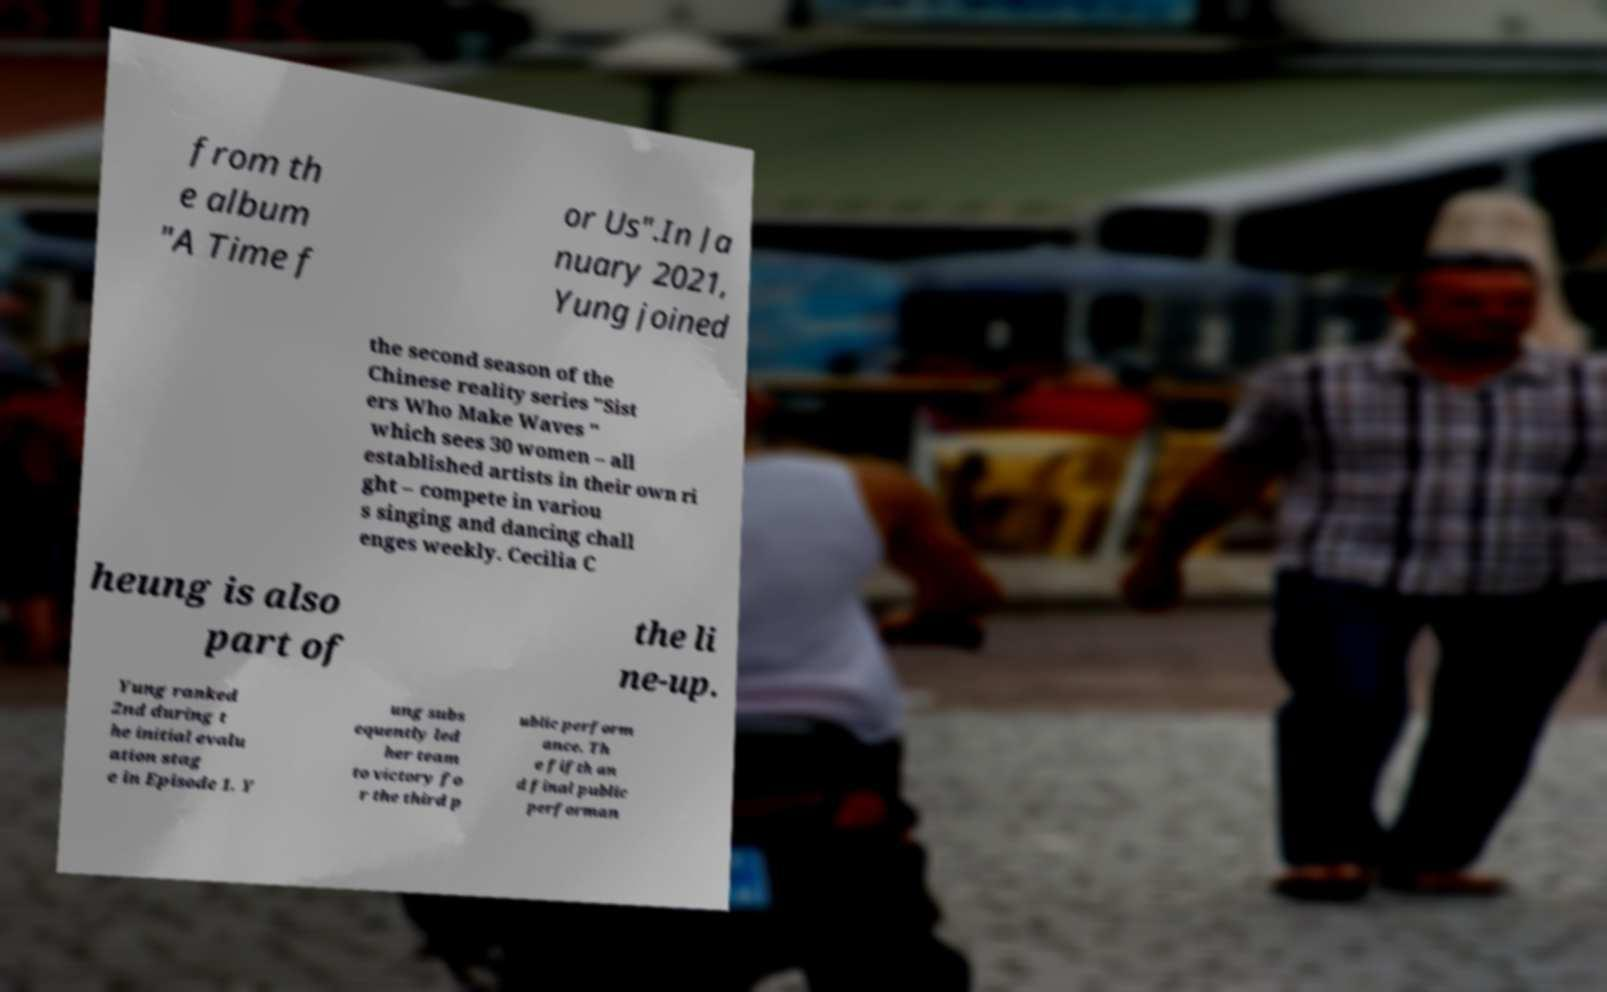Can you accurately transcribe the text from the provided image for me? from th e album "A Time f or Us".In Ja nuary 2021, Yung joined the second season of the Chinese reality series "Sist ers Who Make Waves " which sees 30 women – all established artists in their own ri ght – compete in variou s singing and dancing chall enges weekly. Cecilia C heung is also part of the li ne-up. Yung ranked 2nd during t he initial evalu ation stag e in Episode 1. Y ung subs equently led her team to victory fo r the third p ublic perform ance. Th e fifth an d final public performan 